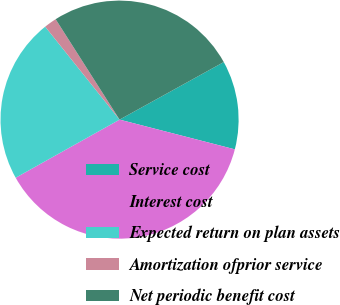<chart> <loc_0><loc_0><loc_500><loc_500><pie_chart><fcel>Service cost<fcel>Interest cost<fcel>Expected return on plan assets<fcel>Amortization ofprior service<fcel>Net periodic benefit cost<nl><fcel>12.05%<fcel>37.87%<fcel>22.38%<fcel>1.72%<fcel>25.99%<nl></chart> 